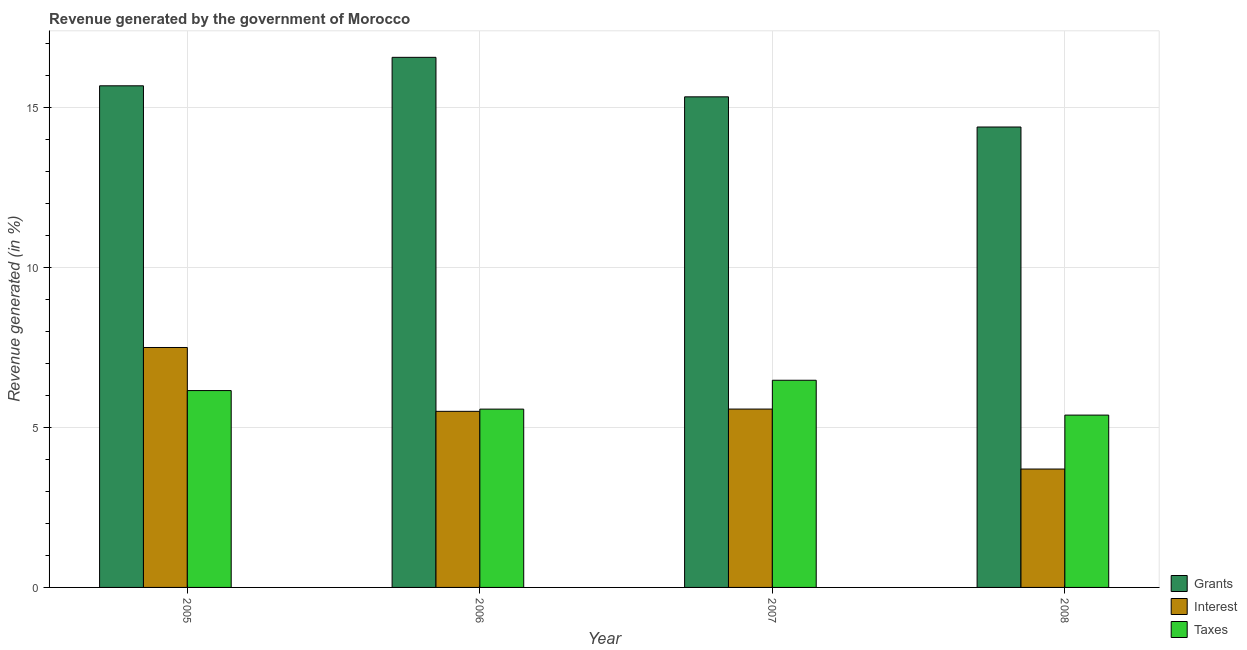Are the number of bars per tick equal to the number of legend labels?
Ensure brevity in your answer.  Yes. Are the number of bars on each tick of the X-axis equal?
Your answer should be compact. Yes. How many bars are there on the 3rd tick from the right?
Offer a very short reply. 3. What is the label of the 2nd group of bars from the left?
Keep it short and to the point. 2006. In how many cases, is the number of bars for a given year not equal to the number of legend labels?
Provide a short and direct response. 0. What is the percentage of revenue generated by interest in 2008?
Offer a very short reply. 3.7. Across all years, what is the maximum percentage of revenue generated by taxes?
Provide a succinct answer. 6.47. Across all years, what is the minimum percentage of revenue generated by taxes?
Offer a very short reply. 5.38. In which year was the percentage of revenue generated by grants minimum?
Give a very brief answer. 2008. What is the total percentage of revenue generated by grants in the graph?
Ensure brevity in your answer.  61.92. What is the difference between the percentage of revenue generated by grants in 2005 and that in 2006?
Your response must be concise. -0.89. What is the difference between the percentage of revenue generated by interest in 2007 and the percentage of revenue generated by grants in 2006?
Your response must be concise. 0.07. What is the average percentage of revenue generated by grants per year?
Your response must be concise. 15.48. In the year 2006, what is the difference between the percentage of revenue generated by taxes and percentage of revenue generated by grants?
Make the answer very short. 0. In how many years, is the percentage of revenue generated by grants greater than 9 %?
Ensure brevity in your answer.  4. What is the ratio of the percentage of revenue generated by taxes in 2007 to that in 2008?
Your answer should be very brief. 1.2. Is the difference between the percentage of revenue generated by interest in 2007 and 2008 greater than the difference between the percentage of revenue generated by grants in 2007 and 2008?
Provide a succinct answer. No. What is the difference between the highest and the second highest percentage of revenue generated by grants?
Keep it short and to the point. 0.89. What is the difference between the highest and the lowest percentage of revenue generated by interest?
Provide a succinct answer. 3.8. What does the 3rd bar from the left in 2008 represents?
Your response must be concise. Taxes. What does the 3rd bar from the right in 2008 represents?
Your answer should be compact. Grants. What is the difference between two consecutive major ticks on the Y-axis?
Provide a short and direct response. 5. Are the values on the major ticks of Y-axis written in scientific E-notation?
Ensure brevity in your answer.  No. Does the graph contain any zero values?
Offer a very short reply. No. Where does the legend appear in the graph?
Your answer should be compact. Bottom right. How are the legend labels stacked?
Give a very brief answer. Vertical. What is the title of the graph?
Ensure brevity in your answer.  Revenue generated by the government of Morocco. What is the label or title of the Y-axis?
Provide a succinct answer. Revenue generated (in %). What is the Revenue generated (in %) of Grants in 2005?
Keep it short and to the point. 15.66. What is the Revenue generated (in %) of Interest in 2005?
Your answer should be compact. 7.49. What is the Revenue generated (in %) in Taxes in 2005?
Keep it short and to the point. 6.15. What is the Revenue generated (in %) in Grants in 2006?
Make the answer very short. 16.55. What is the Revenue generated (in %) in Interest in 2006?
Your answer should be compact. 5.5. What is the Revenue generated (in %) of Taxes in 2006?
Give a very brief answer. 5.57. What is the Revenue generated (in %) in Grants in 2007?
Ensure brevity in your answer.  15.32. What is the Revenue generated (in %) in Interest in 2007?
Provide a short and direct response. 5.57. What is the Revenue generated (in %) in Taxes in 2007?
Your answer should be compact. 6.47. What is the Revenue generated (in %) in Grants in 2008?
Give a very brief answer. 14.38. What is the Revenue generated (in %) in Interest in 2008?
Offer a very short reply. 3.7. What is the Revenue generated (in %) in Taxes in 2008?
Provide a short and direct response. 5.38. Across all years, what is the maximum Revenue generated (in %) of Grants?
Offer a very short reply. 16.55. Across all years, what is the maximum Revenue generated (in %) in Interest?
Your answer should be very brief. 7.49. Across all years, what is the maximum Revenue generated (in %) in Taxes?
Your response must be concise. 6.47. Across all years, what is the minimum Revenue generated (in %) of Grants?
Make the answer very short. 14.38. Across all years, what is the minimum Revenue generated (in %) in Interest?
Your answer should be very brief. 3.7. Across all years, what is the minimum Revenue generated (in %) of Taxes?
Make the answer very short. 5.38. What is the total Revenue generated (in %) in Grants in the graph?
Make the answer very short. 61.92. What is the total Revenue generated (in %) of Interest in the graph?
Provide a short and direct response. 22.26. What is the total Revenue generated (in %) of Taxes in the graph?
Make the answer very short. 23.57. What is the difference between the Revenue generated (in %) of Grants in 2005 and that in 2006?
Offer a terse response. -0.89. What is the difference between the Revenue generated (in %) in Interest in 2005 and that in 2006?
Give a very brief answer. 1.99. What is the difference between the Revenue generated (in %) in Taxes in 2005 and that in 2006?
Ensure brevity in your answer.  0.58. What is the difference between the Revenue generated (in %) in Grants in 2005 and that in 2007?
Make the answer very short. 0.34. What is the difference between the Revenue generated (in %) in Interest in 2005 and that in 2007?
Your answer should be very brief. 1.92. What is the difference between the Revenue generated (in %) in Taxes in 2005 and that in 2007?
Give a very brief answer. -0.32. What is the difference between the Revenue generated (in %) in Grants in 2005 and that in 2008?
Offer a very short reply. 1.29. What is the difference between the Revenue generated (in %) of Interest in 2005 and that in 2008?
Offer a very short reply. 3.8. What is the difference between the Revenue generated (in %) of Taxes in 2005 and that in 2008?
Give a very brief answer. 0.77. What is the difference between the Revenue generated (in %) in Grants in 2006 and that in 2007?
Provide a short and direct response. 1.23. What is the difference between the Revenue generated (in %) in Interest in 2006 and that in 2007?
Give a very brief answer. -0.07. What is the difference between the Revenue generated (in %) of Taxes in 2006 and that in 2007?
Ensure brevity in your answer.  -0.9. What is the difference between the Revenue generated (in %) in Grants in 2006 and that in 2008?
Offer a terse response. 2.18. What is the difference between the Revenue generated (in %) in Interest in 2006 and that in 2008?
Provide a short and direct response. 1.8. What is the difference between the Revenue generated (in %) in Taxes in 2006 and that in 2008?
Give a very brief answer. 0.19. What is the difference between the Revenue generated (in %) of Grants in 2007 and that in 2008?
Offer a terse response. 0.94. What is the difference between the Revenue generated (in %) in Interest in 2007 and that in 2008?
Provide a short and direct response. 1.87. What is the difference between the Revenue generated (in %) in Taxes in 2007 and that in 2008?
Offer a very short reply. 1.09. What is the difference between the Revenue generated (in %) in Grants in 2005 and the Revenue generated (in %) in Interest in 2006?
Your answer should be very brief. 10.17. What is the difference between the Revenue generated (in %) of Grants in 2005 and the Revenue generated (in %) of Taxes in 2006?
Keep it short and to the point. 10.1. What is the difference between the Revenue generated (in %) in Interest in 2005 and the Revenue generated (in %) in Taxes in 2006?
Ensure brevity in your answer.  1.92. What is the difference between the Revenue generated (in %) of Grants in 2005 and the Revenue generated (in %) of Interest in 2007?
Your answer should be compact. 10.1. What is the difference between the Revenue generated (in %) of Grants in 2005 and the Revenue generated (in %) of Taxes in 2007?
Ensure brevity in your answer.  9.2. What is the difference between the Revenue generated (in %) in Interest in 2005 and the Revenue generated (in %) in Taxes in 2007?
Give a very brief answer. 1.02. What is the difference between the Revenue generated (in %) in Grants in 2005 and the Revenue generated (in %) in Interest in 2008?
Make the answer very short. 11.97. What is the difference between the Revenue generated (in %) in Grants in 2005 and the Revenue generated (in %) in Taxes in 2008?
Your answer should be compact. 10.28. What is the difference between the Revenue generated (in %) of Interest in 2005 and the Revenue generated (in %) of Taxes in 2008?
Give a very brief answer. 2.11. What is the difference between the Revenue generated (in %) in Grants in 2006 and the Revenue generated (in %) in Interest in 2007?
Provide a succinct answer. 10.98. What is the difference between the Revenue generated (in %) of Grants in 2006 and the Revenue generated (in %) of Taxes in 2007?
Offer a terse response. 10.08. What is the difference between the Revenue generated (in %) in Interest in 2006 and the Revenue generated (in %) in Taxes in 2007?
Offer a very short reply. -0.97. What is the difference between the Revenue generated (in %) of Grants in 2006 and the Revenue generated (in %) of Interest in 2008?
Keep it short and to the point. 12.86. What is the difference between the Revenue generated (in %) of Grants in 2006 and the Revenue generated (in %) of Taxes in 2008?
Your answer should be compact. 11.17. What is the difference between the Revenue generated (in %) in Interest in 2006 and the Revenue generated (in %) in Taxes in 2008?
Your answer should be compact. 0.12. What is the difference between the Revenue generated (in %) of Grants in 2007 and the Revenue generated (in %) of Interest in 2008?
Provide a succinct answer. 11.62. What is the difference between the Revenue generated (in %) in Grants in 2007 and the Revenue generated (in %) in Taxes in 2008?
Your answer should be compact. 9.94. What is the difference between the Revenue generated (in %) in Interest in 2007 and the Revenue generated (in %) in Taxes in 2008?
Ensure brevity in your answer.  0.19. What is the average Revenue generated (in %) of Grants per year?
Your response must be concise. 15.48. What is the average Revenue generated (in %) in Interest per year?
Keep it short and to the point. 5.56. What is the average Revenue generated (in %) in Taxes per year?
Provide a short and direct response. 5.89. In the year 2005, what is the difference between the Revenue generated (in %) in Grants and Revenue generated (in %) in Interest?
Offer a terse response. 8.17. In the year 2005, what is the difference between the Revenue generated (in %) of Grants and Revenue generated (in %) of Taxes?
Offer a terse response. 9.52. In the year 2005, what is the difference between the Revenue generated (in %) of Interest and Revenue generated (in %) of Taxes?
Provide a succinct answer. 1.35. In the year 2006, what is the difference between the Revenue generated (in %) in Grants and Revenue generated (in %) in Interest?
Provide a short and direct response. 11.05. In the year 2006, what is the difference between the Revenue generated (in %) of Grants and Revenue generated (in %) of Taxes?
Offer a very short reply. 10.99. In the year 2006, what is the difference between the Revenue generated (in %) of Interest and Revenue generated (in %) of Taxes?
Make the answer very short. -0.07. In the year 2007, what is the difference between the Revenue generated (in %) in Grants and Revenue generated (in %) in Interest?
Keep it short and to the point. 9.75. In the year 2007, what is the difference between the Revenue generated (in %) in Grants and Revenue generated (in %) in Taxes?
Offer a very short reply. 8.85. In the year 2007, what is the difference between the Revenue generated (in %) of Interest and Revenue generated (in %) of Taxes?
Offer a very short reply. -0.9. In the year 2008, what is the difference between the Revenue generated (in %) in Grants and Revenue generated (in %) in Interest?
Give a very brief answer. 10.68. In the year 2008, what is the difference between the Revenue generated (in %) in Grants and Revenue generated (in %) in Taxes?
Make the answer very short. 9. In the year 2008, what is the difference between the Revenue generated (in %) of Interest and Revenue generated (in %) of Taxes?
Provide a short and direct response. -1.68. What is the ratio of the Revenue generated (in %) in Grants in 2005 to that in 2006?
Offer a very short reply. 0.95. What is the ratio of the Revenue generated (in %) in Interest in 2005 to that in 2006?
Your response must be concise. 1.36. What is the ratio of the Revenue generated (in %) of Taxes in 2005 to that in 2006?
Keep it short and to the point. 1.1. What is the ratio of the Revenue generated (in %) of Grants in 2005 to that in 2007?
Give a very brief answer. 1.02. What is the ratio of the Revenue generated (in %) in Interest in 2005 to that in 2007?
Your answer should be compact. 1.35. What is the ratio of the Revenue generated (in %) of Taxes in 2005 to that in 2007?
Provide a short and direct response. 0.95. What is the ratio of the Revenue generated (in %) of Grants in 2005 to that in 2008?
Your response must be concise. 1.09. What is the ratio of the Revenue generated (in %) of Interest in 2005 to that in 2008?
Make the answer very short. 2.03. What is the ratio of the Revenue generated (in %) in Taxes in 2005 to that in 2008?
Your answer should be compact. 1.14. What is the ratio of the Revenue generated (in %) in Grants in 2006 to that in 2007?
Ensure brevity in your answer.  1.08. What is the ratio of the Revenue generated (in %) of Interest in 2006 to that in 2007?
Your answer should be compact. 0.99. What is the ratio of the Revenue generated (in %) in Taxes in 2006 to that in 2007?
Your response must be concise. 0.86. What is the ratio of the Revenue generated (in %) of Grants in 2006 to that in 2008?
Your answer should be compact. 1.15. What is the ratio of the Revenue generated (in %) in Interest in 2006 to that in 2008?
Provide a succinct answer. 1.49. What is the ratio of the Revenue generated (in %) of Taxes in 2006 to that in 2008?
Make the answer very short. 1.03. What is the ratio of the Revenue generated (in %) of Grants in 2007 to that in 2008?
Give a very brief answer. 1.07. What is the ratio of the Revenue generated (in %) in Interest in 2007 to that in 2008?
Your answer should be very brief. 1.51. What is the ratio of the Revenue generated (in %) of Taxes in 2007 to that in 2008?
Provide a succinct answer. 1.2. What is the difference between the highest and the second highest Revenue generated (in %) in Grants?
Your response must be concise. 0.89. What is the difference between the highest and the second highest Revenue generated (in %) in Interest?
Provide a succinct answer. 1.92. What is the difference between the highest and the second highest Revenue generated (in %) in Taxes?
Offer a terse response. 0.32. What is the difference between the highest and the lowest Revenue generated (in %) of Grants?
Make the answer very short. 2.18. What is the difference between the highest and the lowest Revenue generated (in %) in Interest?
Provide a short and direct response. 3.8. What is the difference between the highest and the lowest Revenue generated (in %) of Taxes?
Keep it short and to the point. 1.09. 